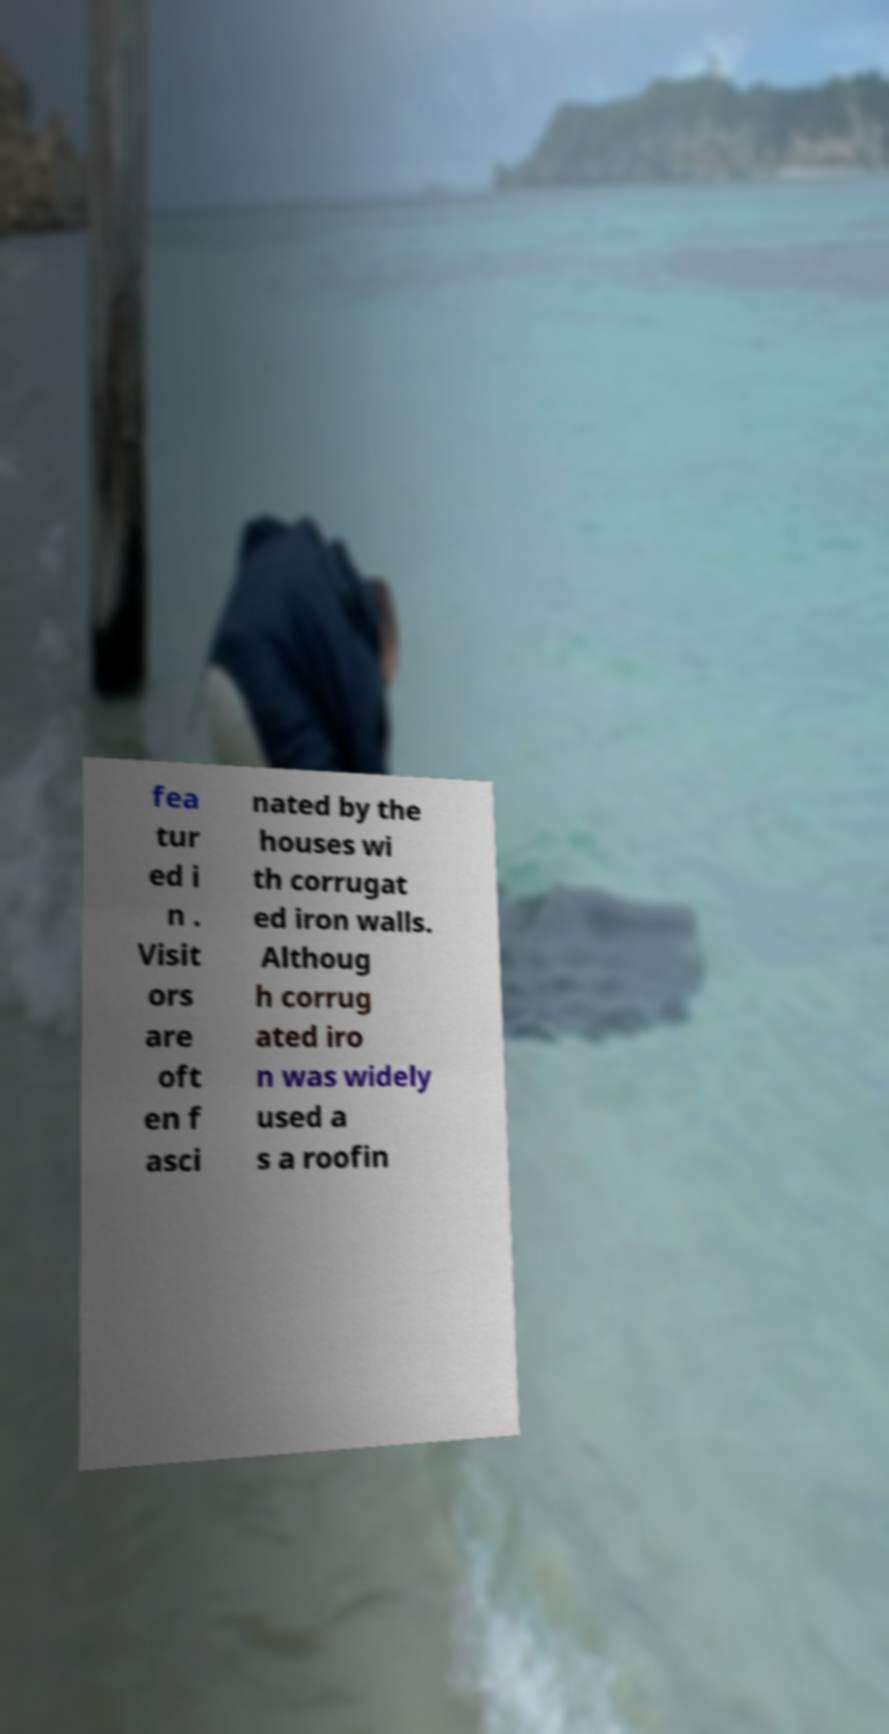For documentation purposes, I need the text within this image transcribed. Could you provide that? fea tur ed i n . Visit ors are oft en f asci nated by the houses wi th corrugat ed iron walls. Althoug h corrug ated iro n was widely used a s a roofin 